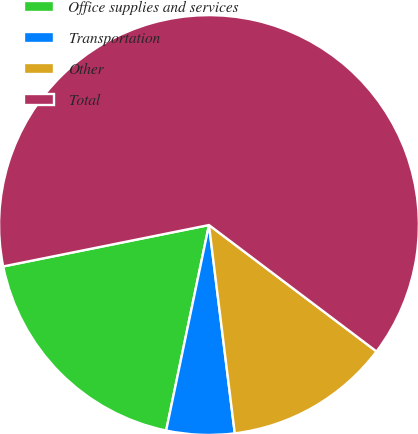Convert chart. <chart><loc_0><loc_0><loc_500><loc_500><pie_chart><fcel>Office supplies and services<fcel>Transportation<fcel>Other<fcel>Total<nl><fcel>18.57%<fcel>5.23%<fcel>12.75%<fcel>63.44%<nl></chart> 